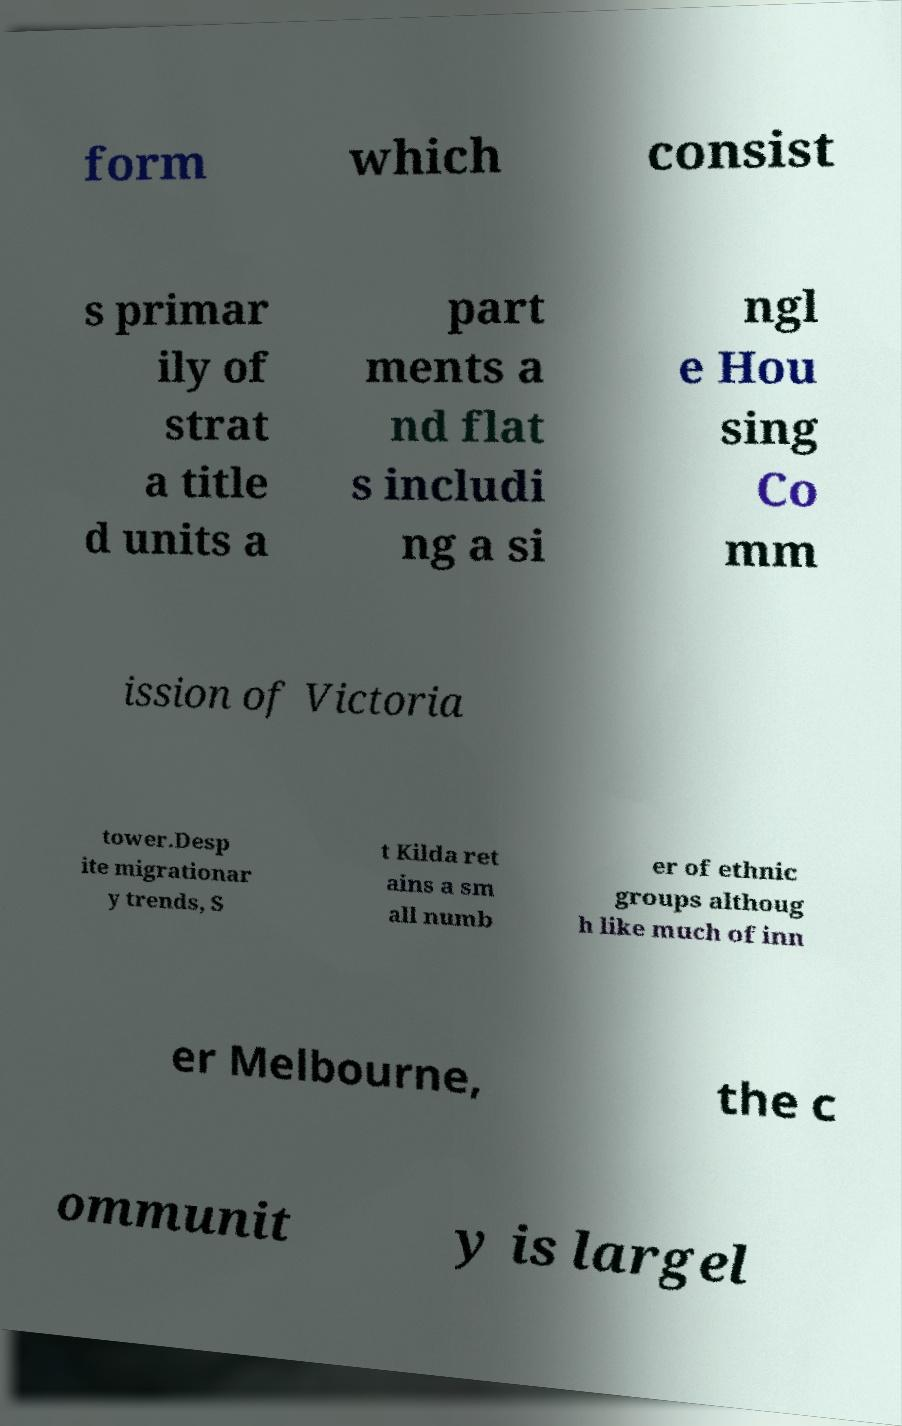Can you read and provide the text displayed in the image?This photo seems to have some interesting text. Can you extract and type it out for me? form which consist s primar ily of strat a title d units a part ments a nd flat s includi ng a si ngl e Hou sing Co mm ission of Victoria tower.Desp ite migrationar y trends, S t Kilda ret ains a sm all numb er of ethnic groups althoug h like much of inn er Melbourne, the c ommunit y is largel 